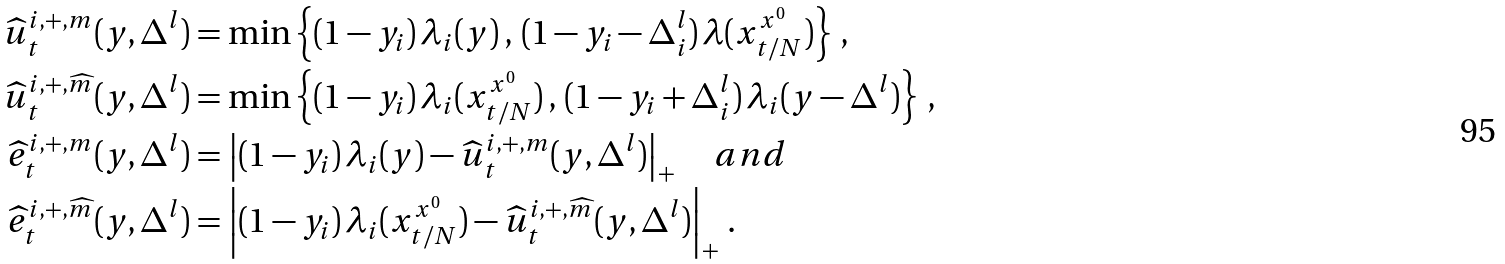<formula> <loc_0><loc_0><loc_500><loc_500>\widehat { u } _ { t } ^ { i , + , m } ( y , \Delta ^ { l } ) & = \min \left \{ ( 1 - y _ { i } ) \, \lambda _ { i } ( y ) \, , \, ( 1 - y _ { i } - \Delta _ { i } ^ { l } ) \, \lambda ( x _ { t / N } ^ { x ^ { 0 } } ) \right \} \, , \\ \widehat { u } _ { t } ^ { i , + , \widehat { m } } ( y , \Delta ^ { l } ) & = \min \left \{ ( 1 - y _ { i } ) \, \lambda _ { i } ( x _ { t / N } ^ { x ^ { 0 } } ) \, , \, ( 1 - y _ { i } + \Delta _ { i } ^ { l } ) \, \lambda _ { i } ( y - \Delta ^ { l } ) \right \} \, , \\ \widehat { e } _ { t } ^ { i , + , m } ( y , \Delta ^ { l } ) & = \left | ( 1 - y _ { i } ) \, \lambda _ { i } ( y ) - \widehat { u } _ { t } ^ { i , + , m } ( y , \Delta ^ { l } ) \right | _ { + } \quad a n d \\ \widehat { e } _ { t } ^ { i , + , \widehat { m } } ( y , \Delta ^ { l } ) & = \left | ( 1 - y _ { i } ) \, \lambda _ { i } ( x _ { t / N } ^ { x ^ { 0 } } ) - \widehat { u } _ { t } ^ { i , + , \widehat { m } } ( y , \Delta ^ { l } ) \right | _ { + } \, .</formula> 